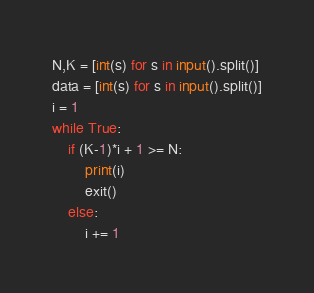<code> <loc_0><loc_0><loc_500><loc_500><_Python_>N,K = [int(s) for s in input().split()]
data = [int(s) for s in input().split()]
i = 1
while True:
    if (K-1)*i + 1 >= N:
        print(i)
        exit()
    else:
        i += 1
</code> 